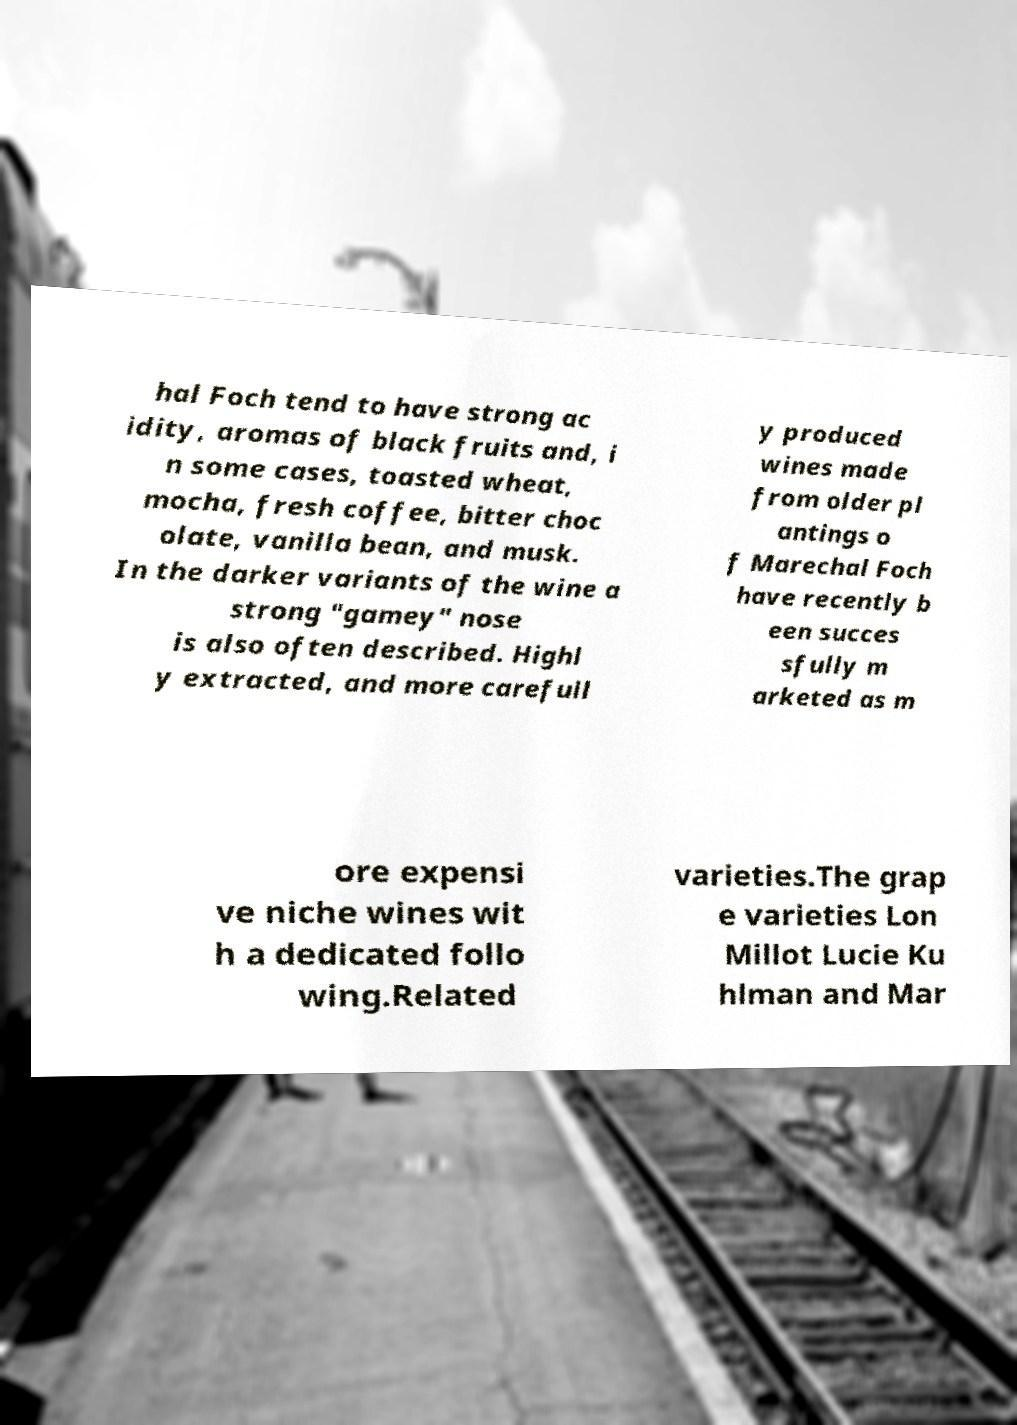What messages or text are displayed in this image? I need them in a readable, typed format. hal Foch tend to have strong ac idity, aromas of black fruits and, i n some cases, toasted wheat, mocha, fresh coffee, bitter choc olate, vanilla bean, and musk. In the darker variants of the wine a strong "gamey" nose is also often described. Highl y extracted, and more carefull y produced wines made from older pl antings o f Marechal Foch have recently b een succes sfully m arketed as m ore expensi ve niche wines wit h a dedicated follo wing.Related varieties.The grap e varieties Lon Millot Lucie Ku hlman and Mar 